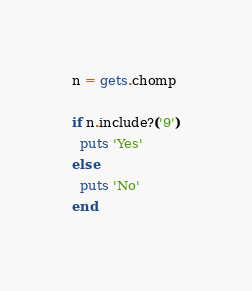<code> <loc_0><loc_0><loc_500><loc_500><_Ruby_>n = gets.chomp

if n.include?('9')
  puts 'Yes'
else
  puts 'No'
end
</code> 